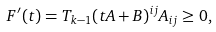<formula> <loc_0><loc_0><loc_500><loc_500>F ^ { \prime } ( t ) = T _ { k - 1 } ( t A + B ) ^ { i j } A _ { i j } \geq 0 ,</formula> 